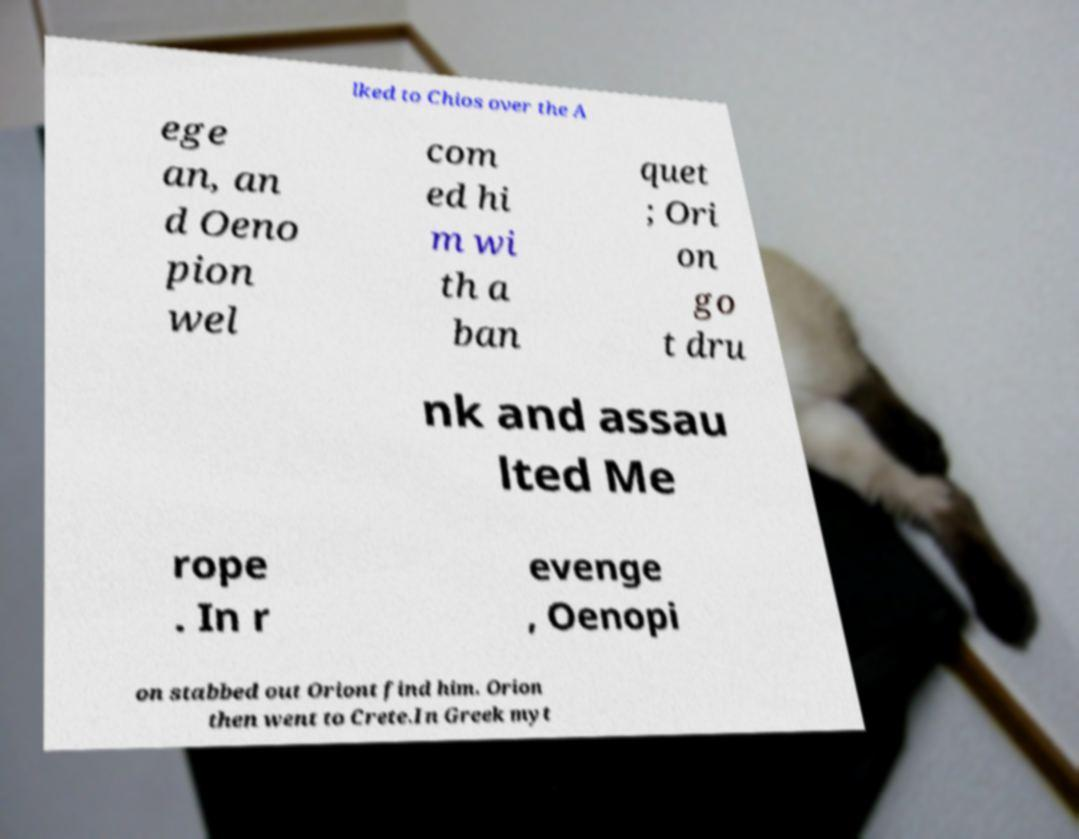Please read and relay the text visible in this image. What does it say? lked to Chios over the A ege an, an d Oeno pion wel com ed hi m wi th a ban quet ; Ori on go t dru nk and assau lted Me rope . In r evenge , Oenopi on stabbed out Oriont find him. Orion then went to Crete.In Greek myt 